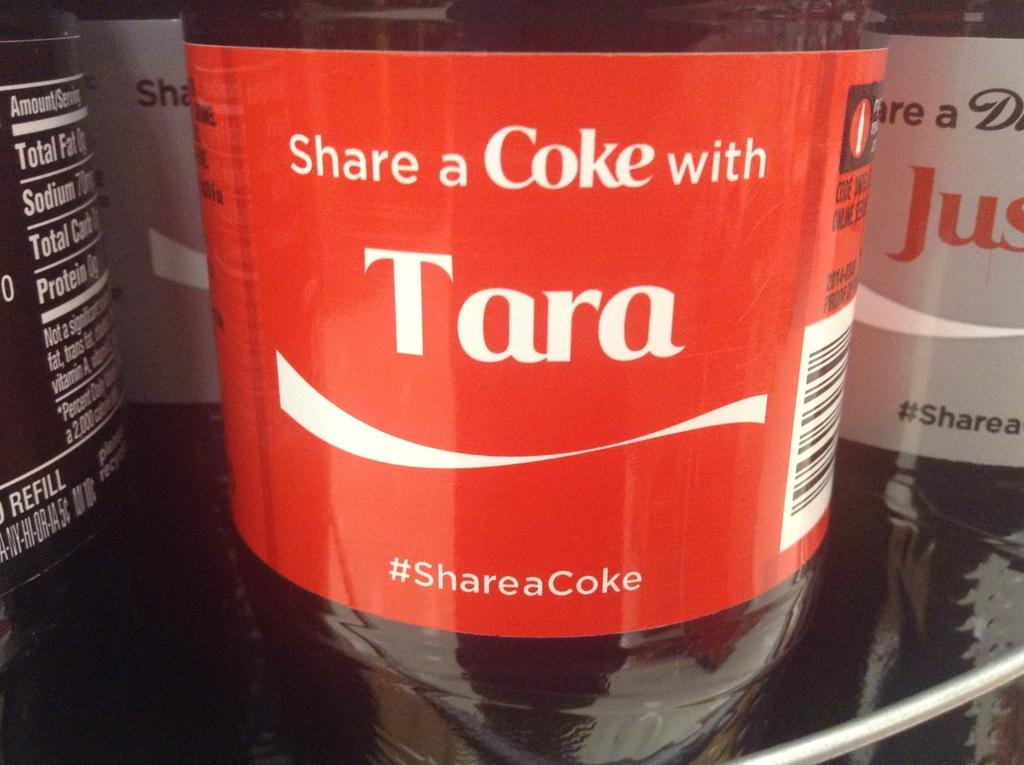Provide a one-sentence caption for the provided image. Coca Cola Drink that says Share a Coke with Tara. 